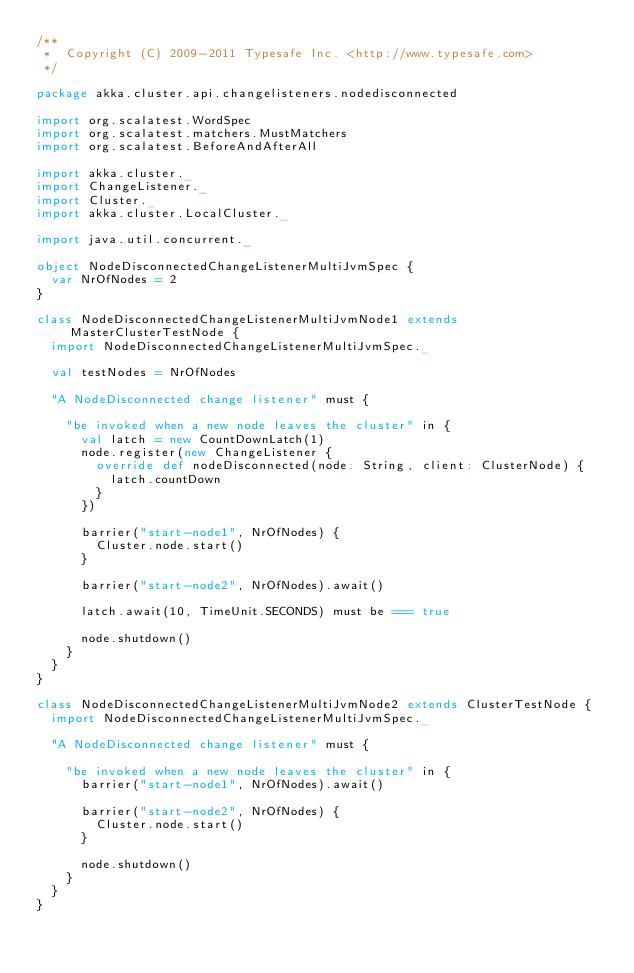Convert code to text. <code><loc_0><loc_0><loc_500><loc_500><_Scala_>/**
 *  Copyright (C) 2009-2011 Typesafe Inc. <http://www.typesafe.com>
 */

package akka.cluster.api.changelisteners.nodedisconnected

import org.scalatest.WordSpec
import org.scalatest.matchers.MustMatchers
import org.scalatest.BeforeAndAfterAll

import akka.cluster._
import ChangeListener._
import Cluster._
import akka.cluster.LocalCluster._

import java.util.concurrent._

object NodeDisconnectedChangeListenerMultiJvmSpec {
  var NrOfNodes = 2
}

class NodeDisconnectedChangeListenerMultiJvmNode1 extends MasterClusterTestNode {
  import NodeDisconnectedChangeListenerMultiJvmSpec._

  val testNodes = NrOfNodes

  "A NodeDisconnected change listener" must {

    "be invoked when a new node leaves the cluster" in {
      val latch = new CountDownLatch(1)
      node.register(new ChangeListener {
        override def nodeDisconnected(node: String, client: ClusterNode) {
          latch.countDown
        }
      })

      barrier("start-node1", NrOfNodes) {
        Cluster.node.start()
      }

      barrier("start-node2", NrOfNodes).await()

      latch.await(10, TimeUnit.SECONDS) must be === true

      node.shutdown()
    }
  }
}

class NodeDisconnectedChangeListenerMultiJvmNode2 extends ClusterTestNode {
  import NodeDisconnectedChangeListenerMultiJvmSpec._

  "A NodeDisconnected change listener" must {

    "be invoked when a new node leaves the cluster" in {
      barrier("start-node1", NrOfNodes).await()

      barrier("start-node2", NrOfNodes) {
        Cluster.node.start()
      }

      node.shutdown()
    }
  }
}
</code> 